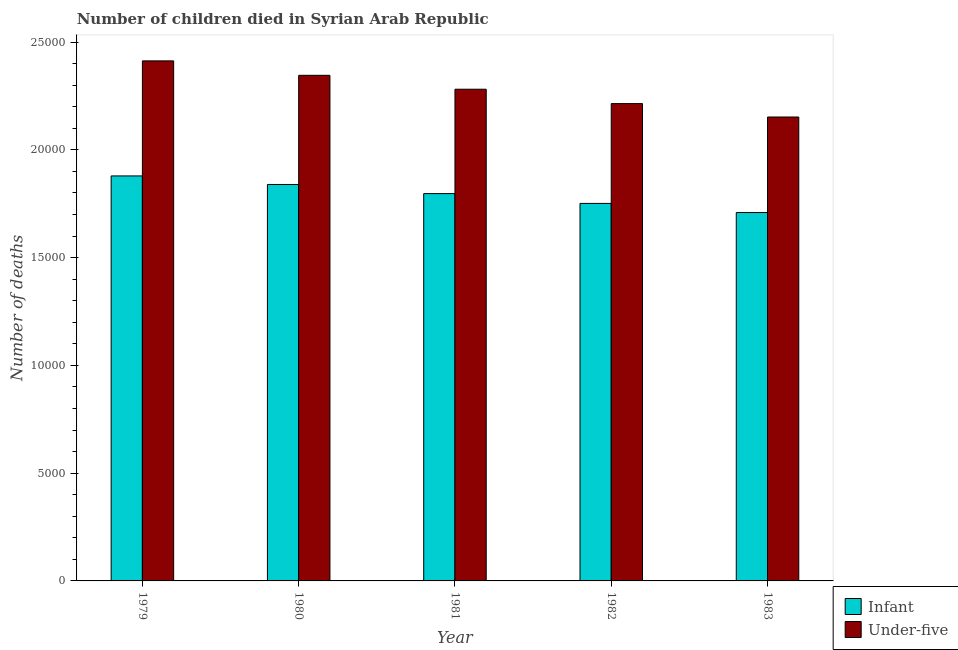Are the number of bars per tick equal to the number of legend labels?
Offer a very short reply. Yes. How many bars are there on the 1st tick from the left?
Make the answer very short. 2. How many bars are there on the 3rd tick from the right?
Keep it short and to the point. 2. What is the number of infant deaths in 1979?
Your response must be concise. 1.88e+04. Across all years, what is the maximum number of under-five deaths?
Ensure brevity in your answer.  2.41e+04. Across all years, what is the minimum number of infant deaths?
Offer a very short reply. 1.71e+04. In which year was the number of infant deaths maximum?
Offer a very short reply. 1979. What is the total number of under-five deaths in the graph?
Your answer should be compact. 1.14e+05. What is the difference between the number of infant deaths in 1980 and that in 1983?
Ensure brevity in your answer.  1302. What is the difference between the number of infant deaths in 1981 and the number of under-five deaths in 1982?
Your response must be concise. 455. What is the average number of under-five deaths per year?
Your response must be concise. 2.28e+04. In the year 1980, what is the difference between the number of infant deaths and number of under-five deaths?
Ensure brevity in your answer.  0. What is the ratio of the number of under-five deaths in 1980 to that in 1982?
Provide a short and direct response. 1.06. Is the number of under-five deaths in 1981 less than that in 1983?
Give a very brief answer. No. What is the difference between the highest and the second highest number of infant deaths?
Your response must be concise. 397. What is the difference between the highest and the lowest number of infant deaths?
Offer a very short reply. 1699. Is the sum of the number of infant deaths in 1982 and 1983 greater than the maximum number of under-five deaths across all years?
Offer a terse response. Yes. What does the 1st bar from the left in 1981 represents?
Provide a short and direct response. Infant. What does the 2nd bar from the right in 1982 represents?
Offer a very short reply. Infant. How many years are there in the graph?
Your answer should be compact. 5. Are the values on the major ticks of Y-axis written in scientific E-notation?
Ensure brevity in your answer.  No. Does the graph contain grids?
Your answer should be very brief. No. Where does the legend appear in the graph?
Offer a very short reply. Bottom right. What is the title of the graph?
Provide a short and direct response. Number of children died in Syrian Arab Republic. What is the label or title of the Y-axis?
Give a very brief answer. Number of deaths. What is the Number of deaths of Infant in 1979?
Keep it short and to the point. 1.88e+04. What is the Number of deaths in Under-five in 1979?
Make the answer very short. 2.41e+04. What is the Number of deaths of Infant in 1980?
Provide a short and direct response. 1.84e+04. What is the Number of deaths in Under-five in 1980?
Provide a succinct answer. 2.35e+04. What is the Number of deaths of Infant in 1981?
Your response must be concise. 1.80e+04. What is the Number of deaths in Under-five in 1981?
Provide a short and direct response. 2.28e+04. What is the Number of deaths of Infant in 1982?
Give a very brief answer. 1.75e+04. What is the Number of deaths of Under-five in 1982?
Offer a terse response. 2.21e+04. What is the Number of deaths of Infant in 1983?
Offer a terse response. 1.71e+04. What is the Number of deaths in Under-five in 1983?
Make the answer very short. 2.15e+04. Across all years, what is the maximum Number of deaths of Infant?
Provide a short and direct response. 1.88e+04. Across all years, what is the maximum Number of deaths in Under-five?
Give a very brief answer. 2.41e+04. Across all years, what is the minimum Number of deaths in Infant?
Your answer should be compact. 1.71e+04. Across all years, what is the minimum Number of deaths in Under-five?
Your response must be concise. 2.15e+04. What is the total Number of deaths in Infant in the graph?
Provide a succinct answer. 8.97e+04. What is the total Number of deaths of Under-five in the graph?
Provide a short and direct response. 1.14e+05. What is the difference between the Number of deaths of Infant in 1979 and that in 1980?
Ensure brevity in your answer.  397. What is the difference between the Number of deaths in Under-five in 1979 and that in 1980?
Your answer should be very brief. 670. What is the difference between the Number of deaths of Infant in 1979 and that in 1981?
Give a very brief answer. 820. What is the difference between the Number of deaths in Under-five in 1979 and that in 1981?
Your response must be concise. 1315. What is the difference between the Number of deaths of Infant in 1979 and that in 1982?
Your response must be concise. 1275. What is the difference between the Number of deaths in Under-five in 1979 and that in 1982?
Provide a short and direct response. 1982. What is the difference between the Number of deaths of Infant in 1979 and that in 1983?
Make the answer very short. 1699. What is the difference between the Number of deaths of Under-five in 1979 and that in 1983?
Provide a short and direct response. 2604. What is the difference between the Number of deaths in Infant in 1980 and that in 1981?
Your answer should be compact. 423. What is the difference between the Number of deaths of Under-five in 1980 and that in 1981?
Your response must be concise. 645. What is the difference between the Number of deaths of Infant in 1980 and that in 1982?
Provide a short and direct response. 878. What is the difference between the Number of deaths in Under-five in 1980 and that in 1982?
Keep it short and to the point. 1312. What is the difference between the Number of deaths in Infant in 1980 and that in 1983?
Make the answer very short. 1302. What is the difference between the Number of deaths in Under-five in 1980 and that in 1983?
Provide a short and direct response. 1934. What is the difference between the Number of deaths in Infant in 1981 and that in 1982?
Provide a short and direct response. 455. What is the difference between the Number of deaths of Under-five in 1981 and that in 1982?
Make the answer very short. 667. What is the difference between the Number of deaths in Infant in 1981 and that in 1983?
Your response must be concise. 879. What is the difference between the Number of deaths in Under-five in 1981 and that in 1983?
Offer a terse response. 1289. What is the difference between the Number of deaths in Infant in 1982 and that in 1983?
Provide a short and direct response. 424. What is the difference between the Number of deaths of Under-five in 1982 and that in 1983?
Your answer should be very brief. 622. What is the difference between the Number of deaths in Infant in 1979 and the Number of deaths in Under-five in 1980?
Your answer should be compact. -4667. What is the difference between the Number of deaths of Infant in 1979 and the Number of deaths of Under-five in 1981?
Offer a very short reply. -4022. What is the difference between the Number of deaths of Infant in 1979 and the Number of deaths of Under-five in 1982?
Provide a short and direct response. -3355. What is the difference between the Number of deaths of Infant in 1979 and the Number of deaths of Under-five in 1983?
Provide a short and direct response. -2733. What is the difference between the Number of deaths in Infant in 1980 and the Number of deaths in Under-five in 1981?
Your answer should be compact. -4419. What is the difference between the Number of deaths in Infant in 1980 and the Number of deaths in Under-five in 1982?
Give a very brief answer. -3752. What is the difference between the Number of deaths of Infant in 1980 and the Number of deaths of Under-five in 1983?
Your response must be concise. -3130. What is the difference between the Number of deaths in Infant in 1981 and the Number of deaths in Under-five in 1982?
Provide a succinct answer. -4175. What is the difference between the Number of deaths of Infant in 1981 and the Number of deaths of Under-five in 1983?
Provide a short and direct response. -3553. What is the difference between the Number of deaths in Infant in 1982 and the Number of deaths in Under-five in 1983?
Provide a succinct answer. -4008. What is the average Number of deaths in Infant per year?
Provide a short and direct response. 1.79e+04. What is the average Number of deaths of Under-five per year?
Your response must be concise. 2.28e+04. In the year 1979, what is the difference between the Number of deaths in Infant and Number of deaths in Under-five?
Your answer should be very brief. -5337. In the year 1980, what is the difference between the Number of deaths in Infant and Number of deaths in Under-five?
Keep it short and to the point. -5064. In the year 1981, what is the difference between the Number of deaths of Infant and Number of deaths of Under-five?
Give a very brief answer. -4842. In the year 1982, what is the difference between the Number of deaths of Infant and Number of deaths of Under-five?
Your answer should be very brief. -4630. In the year 1983, what is the difference between the Number of deaths in Infant and Number of deaths in Under-five?
Your answer should be very brief. -4432. What is the ratio of the Number of deaths of Infant in 1979 to that in 1980?
Offer a very short reply. 1.02. What is the ratio of the Number of deaths of Under-five in 1979 to that in 1980?
Provide a short and direct response. 1.03. What is the ratio of the Number of deaths of Infant in 1979 to that in 1981?
Ensure brevity in your answer.  1.05. What is the ratio of the Number of deaths in Under-five in 1979 to that in 1981?
Ensure brevity in your answer.  1.06. What is the ratio of the Number of deaths of Infant in 1979 to that in 1982?
Your answer should be very brief. 1.07. What is the ratio of the Number of deaths of Under-five in 1979 to that in 1982?
Offer a very short reply. 1.09. What is the ratio of the Number of deaths of Infant in 1979 to that in 1983?
Ensure brevity in your answer.  1.1. What is the ratio of the Number of deaths in Under-five in 1979 to that in 1983?
Your answer should be very brief. 1.12. What is the ratio of the Number of deaths of Infant in 1980 to that in 1981?
Your answer should be very brief. 1.02. What is the ratio of the Number of deaths of Under-five in 1980 to that in 1981?
Provide a short and direct response. 1.03. What is the ratio of the Number of deaths in Infant in 1980 to that in 1982?
Your response must be concise. 1.05. What is the ratio of the Number of deaths of Under-five in 1980 to that in 1982?
Your answer should be compact. 1.06. What is the ratio of the Number of deaths of Infant in 1980 to that in 1983?
Offer a terse response. 1.08. What is the ratio of the Number of deaths in Under-five in 1980 to that in 1983?
Give a very brief answer. 1.09. What is the ratio of the Number of deaths in Infant in 1981 to that in 1982?
Your answer should be very brief. 1.03. What is the ratio of the Number of deaths in Under-five in 1981 to that in 1982?
Ensure brevity in your answer.  1.03. What is the ratio of the Number of deaths in Infant in 1981 to that in 1983?
Keep it short and to the point. 1.05. What is the ratio of the Number of deaths in Under-five in 1981 to that in 1983?
Keep it short and to the point. 1.06. What is the ratio of the Number of deaths of Infant in 1982 to that in 1983?
Your answer should be very brief. 1.02. What is the ratio of the Number of deaths of Under-five in 1982 to that in 1983?
Provide a succinct answer. 1.03. What is the difference between the highest and the second highest Number of deaths of Infant?
Make the answer very short. 397. What is the difference between the highest and the second highest Number of deaths in Under-five?
Offer a terse response. 670. What is the difference between the highest and the lowest Number of deaths in Infant?
Ensure brevity in your answer.  1699. What is the difference between the highest and the lowest Number of deaths of Under-five?
Your response must be concise. 2604. 